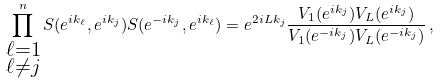<formula> <loc_0><loc_0><loc_500><loc_500>\prod _ { \substack { \ell = 1 \\ \ell \neq j } } ^ { n } S ( e ^ { i k _ { \ell } } , e ^ { i k _ { j } } ) S ( e ^ { - i k _ { j } } , e ^ { i k _ { \ell } } ) = e ^ { 2 i L k _ { j } } \frac { V _ { 1 } ( e ^ { i k _ { j } } ) V _ { L } ( e ^ { i k _ { j } } ) } { V _ { 1 } ( e ^ { - i k _ { j } } ) V _ { L } ( e ^ { - i k _ { j } } ) } \, ,</formula> 